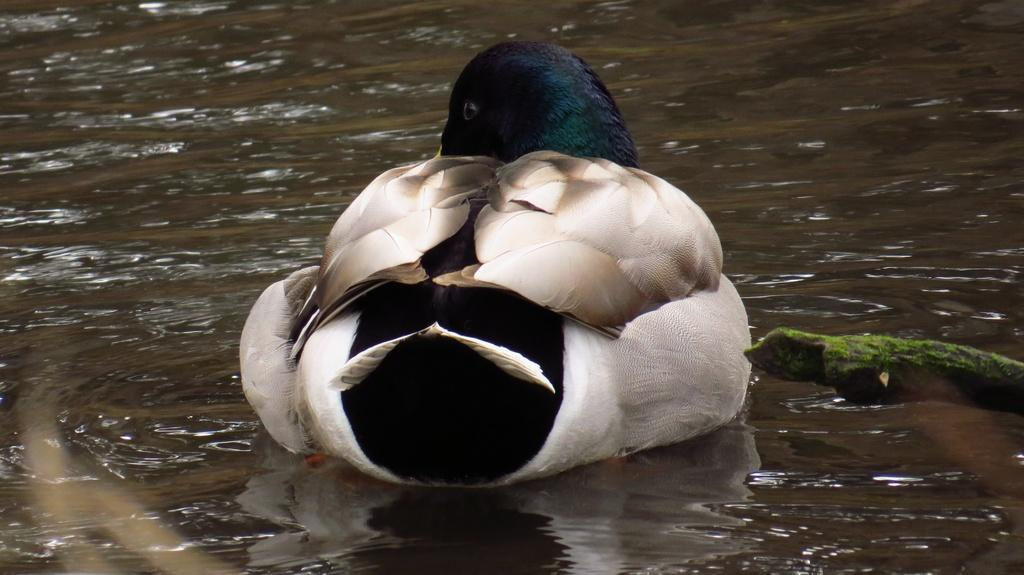What type of animal is in the image? There is a bird in the image. Where is the bird located? The bird is on the water. What color can be seen in the image besides the bird and water? There is something in green color in the image. What type of noise can be heard coming from the women in the image? There are no women present in the image, so it's not possible to determine what noise might be heard. What is the bird's level of wealth in the image? Birds do not have wealth, so this question cannot be answered. 